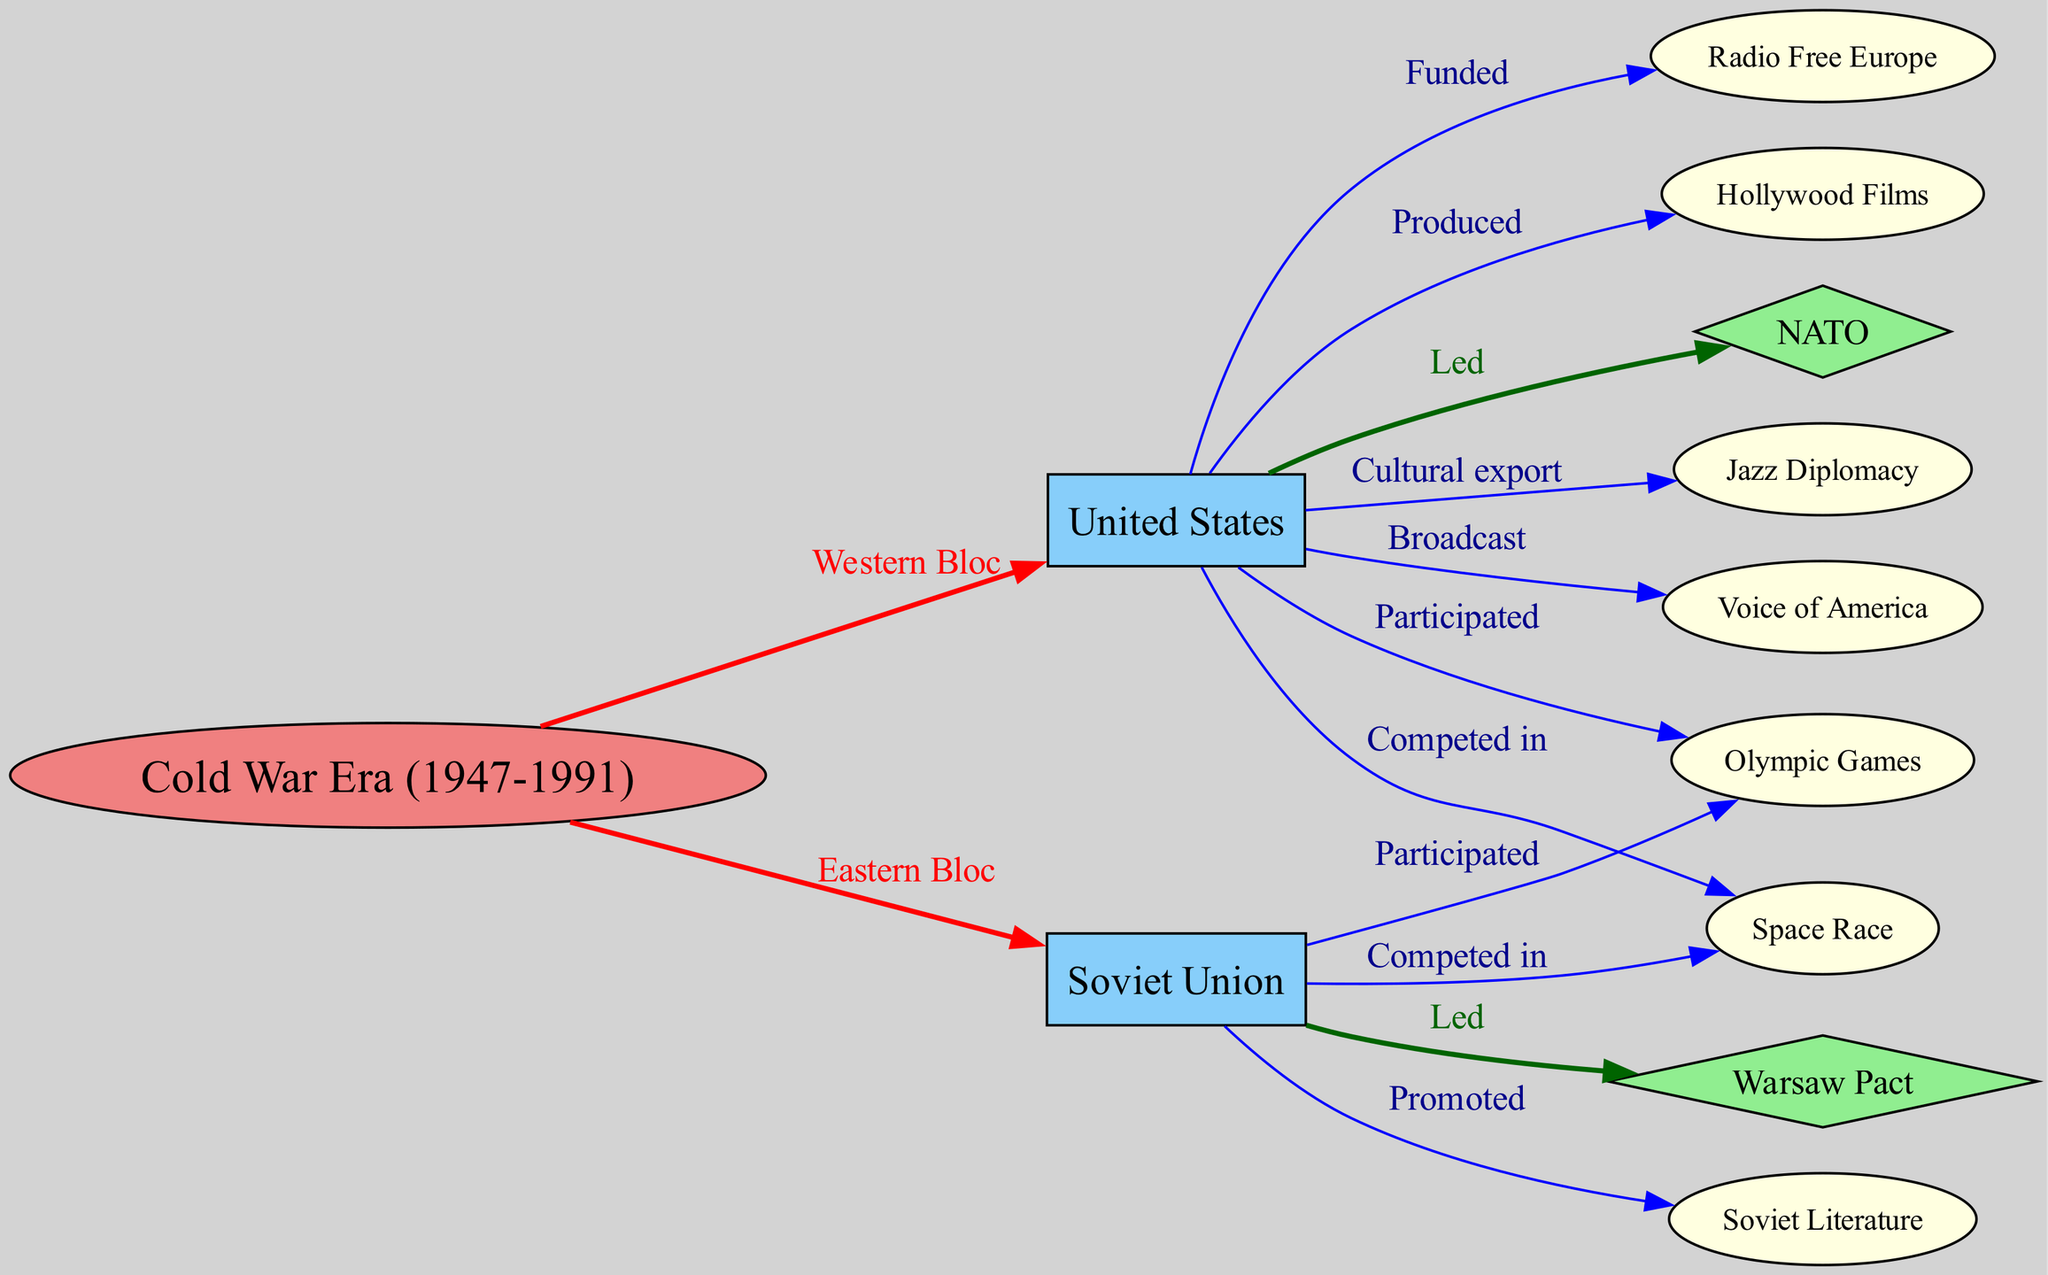What are the two main blocs represented in the diagram? The diagram identifies two primary cultural and political blocs during the Cold War, namely the Western Bloc (represented by the United States) and the Eastern Bloc (represented by the Soviet Union).
Answer: Western Bloc, Eastern Bloc How many nodes are there in the diagram? Counting all the distinct entities listed within the nodes section of the diagram provides a total of 12 nodes, each representing an integral part of the cultural and military dynamics of the Cold War.
Answer: 12 What event is connected to both the United States and the Soviet Union through participation? Both the United States and the Soviet Union participated in the Olympic Games, which is indicated by the direct connections from both nodes to the Olympic Games node in the diagram.
Answer: Olympic Games Which cultural initiative is specifically noted as a cultural export from the United States? The diagram highlights Jazz Diplomacy as a significant cultural initiative that the United States employed to foster goodwill and cultural exchange during the Cold War, making it a stated cultural export.
Answer: Jazz Diplomacy What ideology does the Voice of America represent in its connection to the United States? The Voice of America serves as an ideological export that carries the principles of democracy and capitalism, representing the broader American values and perspectives intended to counteract Soviet influences, as shown in its directional link from the USA.
Answer: Democracy, Capitalism Which organization was led by the Soviet Union and what was its counterpart in the Western Bloc? The Warsaw Pact was established as a counter to NATO during the Cold War, with NATO being led by the United States, indicating the ideological divisions and military alliances of the two opposing sides.
Answer: Warsaw Pact, NATO What does the relationship between the United States and Hollywood Films imply in the context of cultural exchange? The United States' production of Hollywood Films suggests that these movies were not only entertainment but served as a tool for cultural diplomacy, projecting American ideals and lifestyles to audiences worldwide, enhancing its soft power in contrast to Soviet culture.
Answer: Cultural diplomacy Which two key events highlighted competition between the USA and USSR? The diagram illustrates that both the Space Race and the Olympic Games represent significant arenas where the USA and USSR competed against each other, showcasing their rivalry beyond military confrontations.
Answer: Space Race, Olympic Games How did the Soviet Union promote its own cultural narrative according to the diagram? The diagram indicates that Soviet literature was actively promoted by the Soviet Union as part of their cultural strategy, aiming to enhance ideological solidarity and support the state’s philosophy.
Answer: Soviet Literature 